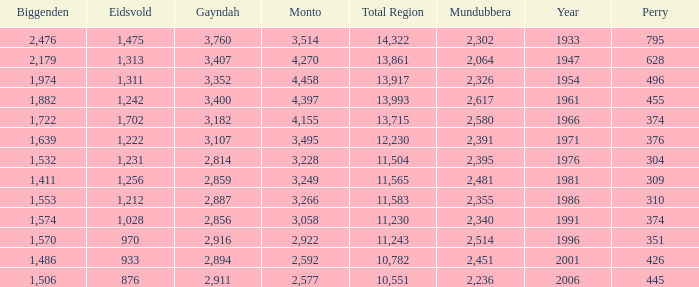Which is the year with Mundubbera being smaller than 2,395, and Biggenden smaller than 1,506? None. 